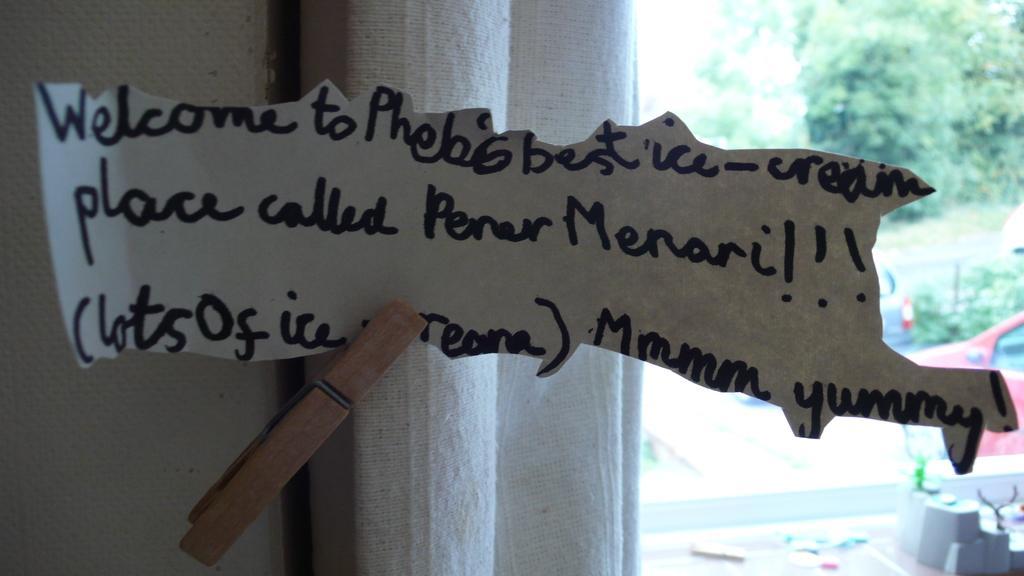How would you summarize this image in a sentence or two? In this image we can see a paper with some text and it is attached to the curtain with a cloth clip and we can see a wall. Through the glass we can see two vehicles, trees and the image is blurred. 